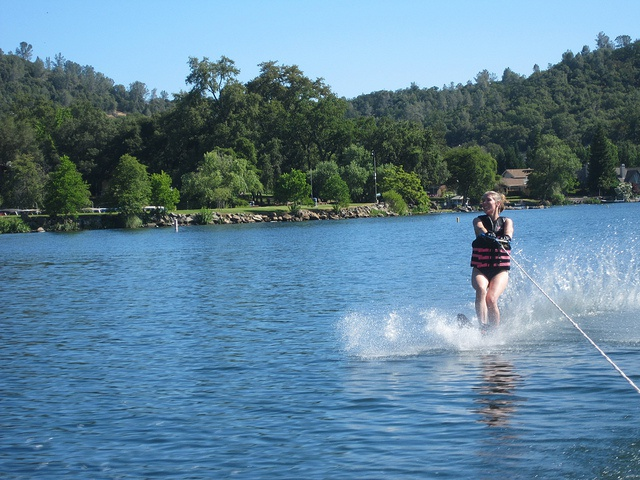Describe the objects in this image and their specific colors. I can see people in lightblue, black, lightgray, gray, and darkgray tones in this image. 